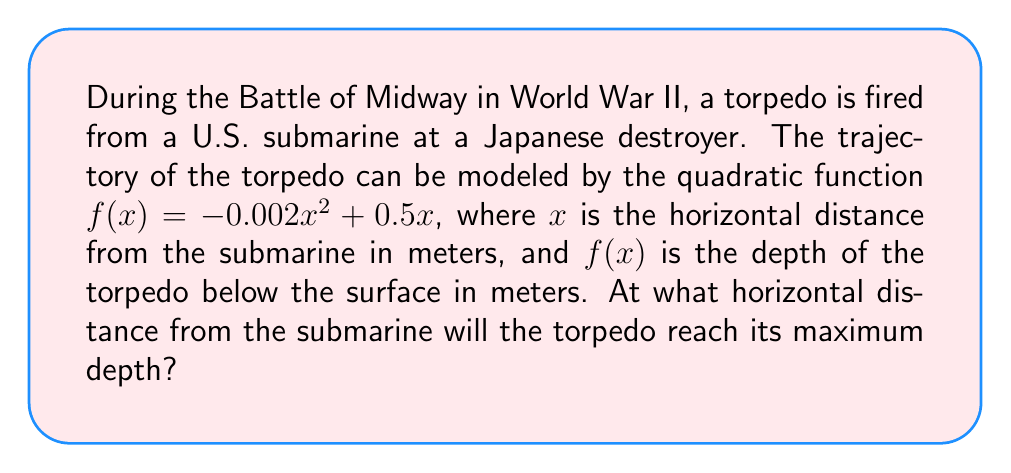Teach me how to tackle this problem. To find the horizontal distance at which the torpedo reaches its maximum depth, we need to follow these steps:

1) The quadratic function is in the form $f(x) = ax^2 + bx + c$, where:
   $a = -0.002$
   $b = 0.5$
   $c = 0$

2) For a quadratic function, the x-coordinate of the vertex represents the point where the function reaches its maximum (if $a < 0$) or minimum (if $a > 0$).

3) The formula for the x-coordinate of the vertex is:
   $$x = -\frac{b}{2a}$$

4) Substituting our values:
   $$x = -\frac{0.5}{2(-0.002)}$$

5) Simplifying:
   $$x = -\frac{0.5}{-0.004} = \frac{0.5}{0.004} = 125$$

Therefore, the torpedo will reach its maximum depth 125 meters horizontally from the submarine.
Answer: 125 meters 